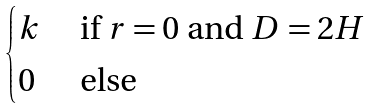<formula> <loc_0><loc_0><loc_500><loc_500>\begin{cases} k & \text { if } r = 0 \text { and } D = 2 H \\ 0 & \text { else} \end{cases}</formula> 